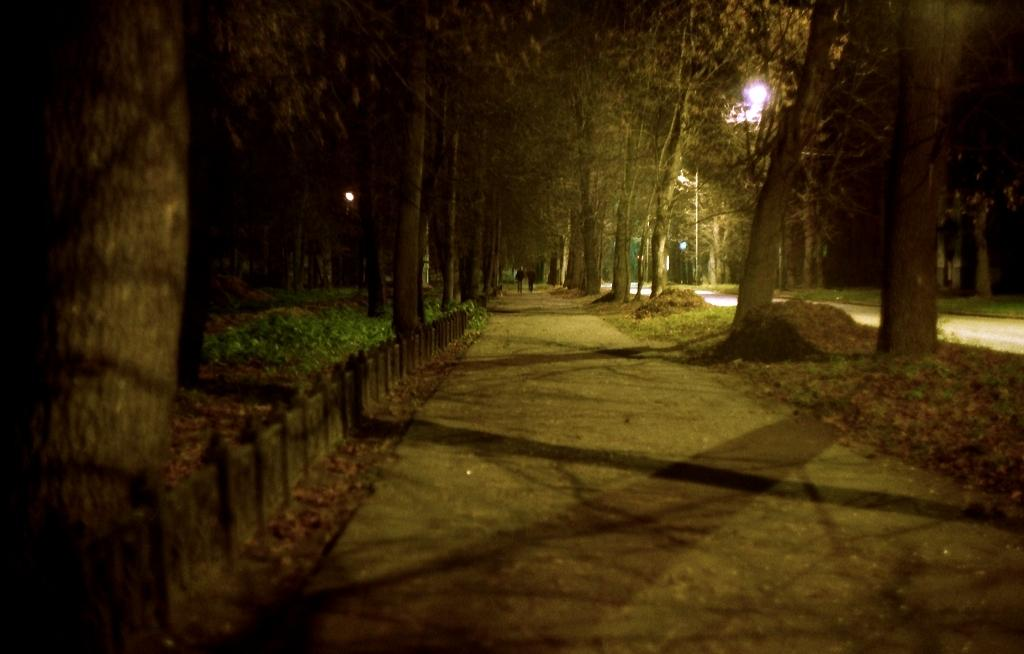How many people are in the image? There are two people in the image. What are the people wearing? The people are wearing clothes. What are the people doing in the image? The people are walking. What type of surface are the people walking on? There is a footpath in the image. What type of vegetation is present in the image? There is grass and trees in the image. What type of lighting is present in the image? There is a light in the image. What structure is present in the image? There is a pole in the image. What type of maid can be seen cleaning the zinc roof in the image? There is no maid or zinc roof present in the image. 